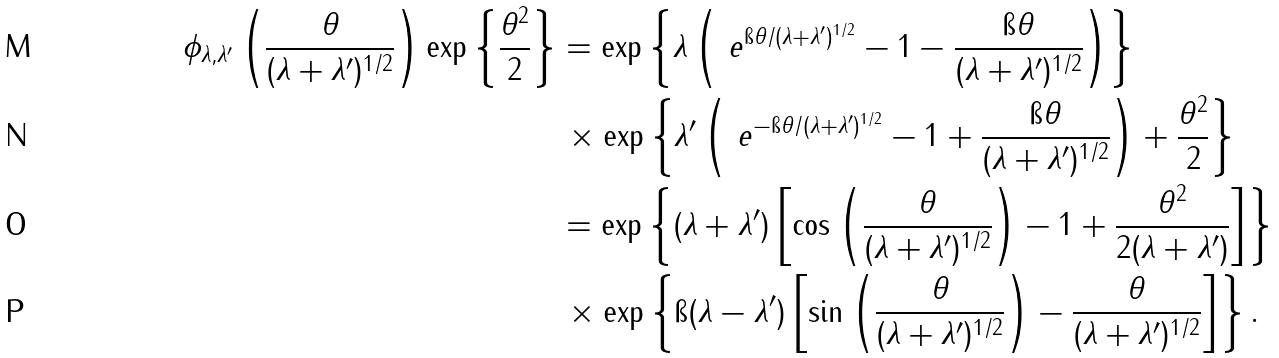Convert formula to latex. <formula><loc_0><loc_0><loc_500><loc_500>\phi _ { \lambda , \lambda ^ { \prime } } \left ( \frac { \theta } { ( \lambda + \lambda ^ { \prime } ) ^ { 1 / 2 } } \right ) \exp \left \{ \frac { \theta ^ { 2 } } { 2 } \right \} & = \exp \left \{ \lambda \left ( \ e ^ { \i \theta / ( \lambda + \lambda ^ { \prime } ) ^ { 1 / 2 } } - 1 - \frac { \i \theta } { ( \lambda + \lambda ^ { \prime } ) ^ { 1 / 2 } } \right ) \right \} \\ & \, \times \exp \left \{ \lambda ^ { \prime } \left ( \ e ^ { - \i \theta / ( \lambda + \lambda ^ { \prime } ) ^ { 1 / 2 } } - 1 + \frac { \i \theta } { ( \lambda + \lambda ^ { \prime } ) ^ { 1 / 2 } } \right ) + \frac { \theta ^ { 2 } } { 2 } \right \} \\ & = \exp \left \{ ( \lambda + \lambda ^ { \prime } ) \left [ \cos \left ( \frac { \theta } { ( \lambda + \lambda ^ { \prime } ) ^ { 1 / 2 } } \right ) - 1 + \frac { \theta ^ { 2 } } { 2 ( \lambda + \lambda ^ { \prime } ) } \right ] \right \} \\ & \, \times \exp \left \{ \i ( \lambda - \lambda ^ { \prime } ) \left [ \sin \left ( \frac { \theta } { ( \lambda + \lambda ^ { \prime } ) ^ { 1 / 2 } } \right ) - \frac { \theta } { ( \lambda + \lambda ^ { \prime } ) ^ { 1 / 2 } } \right ] \right \} .</formula> 